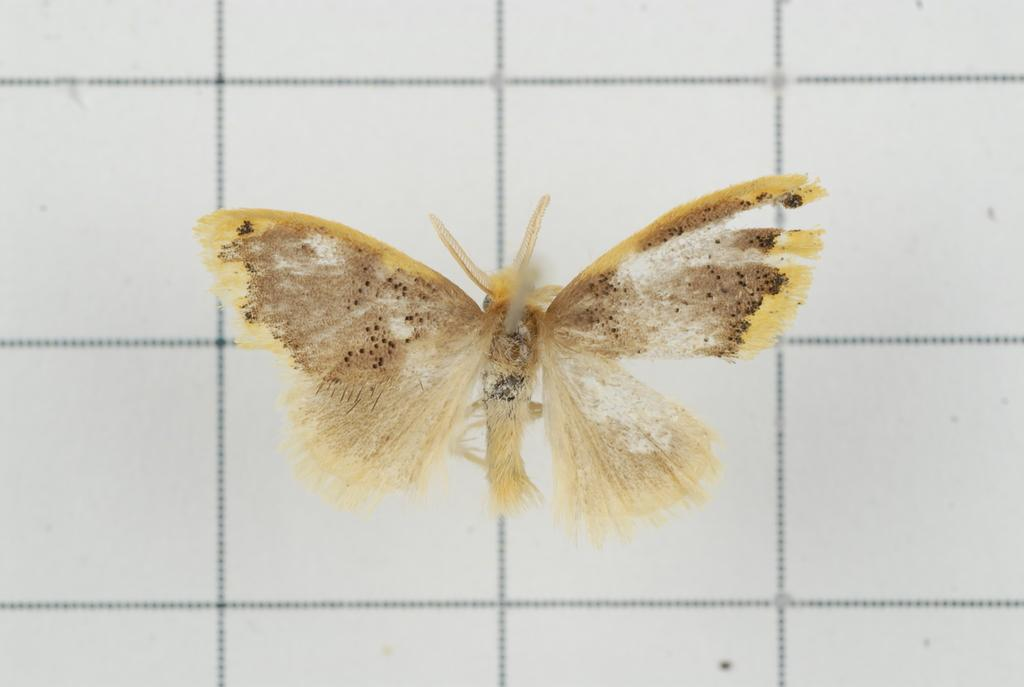What type of insect is in the image? There is a yellow moth in the image. What is the moth standing on? The moth is standing on a tiled floor. What type of school is visible in the image? There is no school present in the image; it features a yellow moth standing on a tiled floor. Can you tell me who the moth's partner is in the image? There is no partner mentioned or visible in the image; it only shows a yellow moth standing on a tiled floor. 